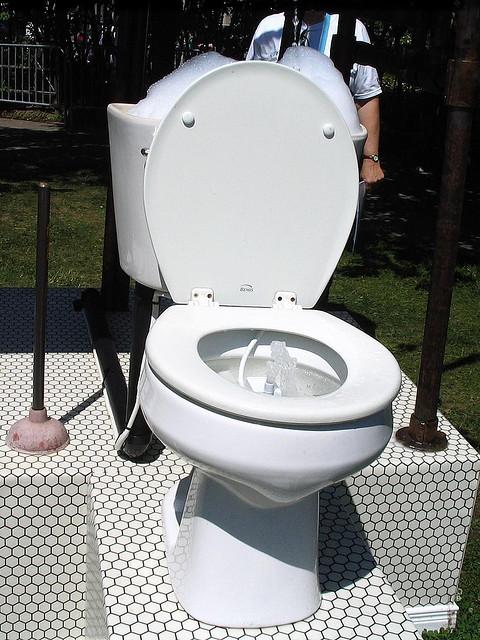How many people do you see?
Give a very brief answer. 1. Is there a toilet?
Answer briefly. Yes. Is there a plunger?
Keep it brief. Yes. 